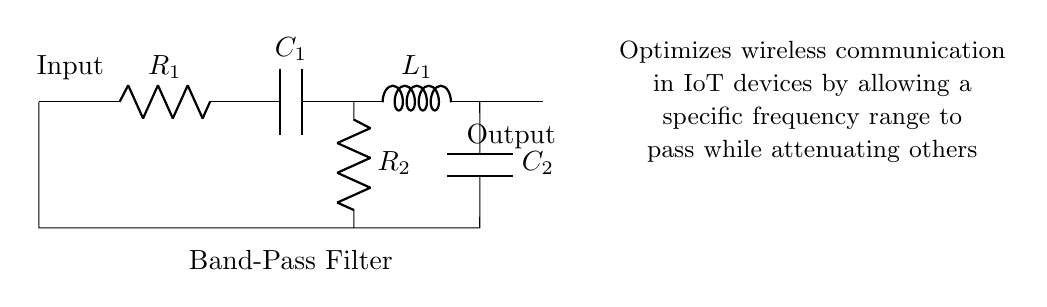What is the input component of this circuit? The input component is the resistor denoted as R1, which is the first element receiving the signal in the circuit.
Answer: R1 How many capacitors are in the circuit? The circuit contains two capacitors, C1 and C2, which serve different functions in the band-pass filter.
Answer: 2 What role does the inductor play in this circuit? The inductor, labeled as L1, works in conjunction with the capacitors to form the low-pass filtering part of the band-pass filter, allowing some frequencies to pass while blocking others.
Answer: Low-pass filter What is the overall function of this filter? The filter selectively allows a specific frequency range to pass through while attenuating frequencies outside that range to optimize wireless communication.
Answer: Band-pass filter Which component connects the high-pass and low-pass sections? The capacitor C2 connects the high-pass section to the low-pass section of the circuit, allowing the desired frequency range to pass.
Answer: C2 What is the output of the circuit labeled as? The output of the circuit is simply labeled as "Output," indicating where the filtered signal is available for use in the IoT device.
Answer: Output 